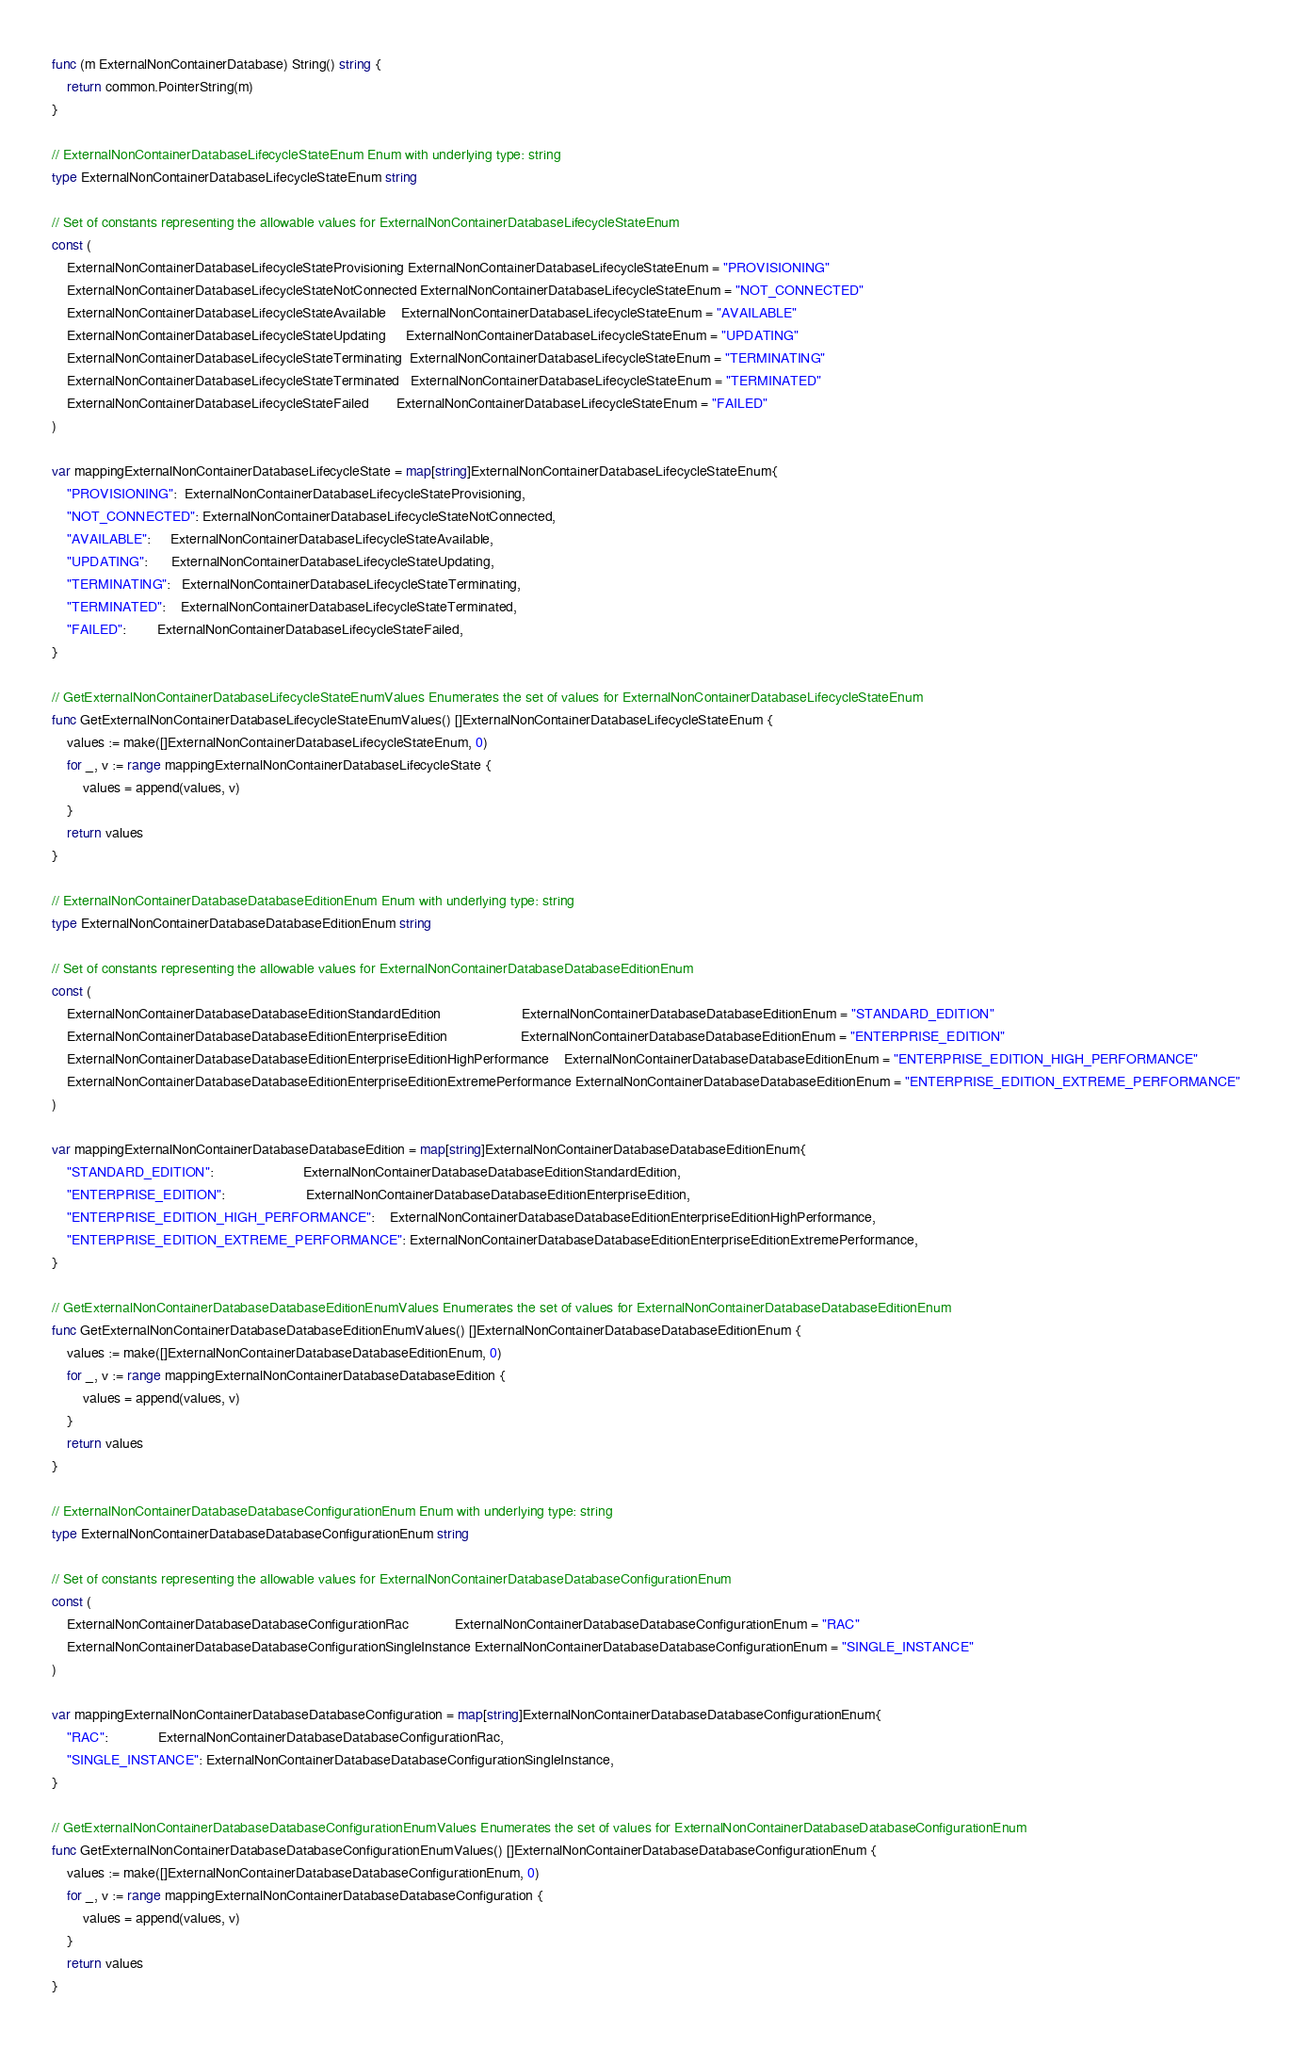<code> <loc_0><loc_0><loc_500><loc_500><_Go_>func (m ExternalNonContainerDatabase) String() string {
	return common.PointerString(m)
}

// ExternalNonContainerDatabaseLifecycleStateEnum Enum with underlying type: string
type ExternalNonContainerDatabaseLifecycleStateEnum string

// Set of constants representing the allowable values for ExternalNonContainerDatabaseLifecycleStateEnum
const (
	ExternalNonContainerDatabaseLifecycleStateProvisioning ExternalNonContainerDatabaseLifecycleStateEnum = "PROVISIONING"
	ExternalNonContainerDatabaseLifecycleStateNotConnected ExternalNonContainerDatabaseLifecycleStateEnum = "NOT_CONNECTED"
	ExternalNonContainerDatabaseLifecycleStateAvailable    ExternalNonContainerDatabaseLifecycleStateEnum = "AVAILABLE"
	ExternalNonContainerDatabaseLifecycleStateUpdating     ExternalNonContainerDatabaseLifecycleStateEnum = "UPDATING"
	ExternalNonContainerDatabaseLifecycleStateTerminating  ExternalNonContainerDatabaseLifecycleStateEnum = "TERMINATING"
	ExternalNonContainerDatabaseLifecycleStateTerminated   ExternalNonContainerDatabaseLifecycleStateEnum = "TERMINATED"
	ExternalNonContainerDatabaseLifecycleStateFailed       ExternalNonContainerDatabaseLifecycleStateEnum = "FAILED"
)

var mappingExternalNonContainerDatabaseLifecycleState = map[string]ExternalNonContainerDatabaseLifecycleStateEnum{
	"PROVISIONING":  ExternalNonContainerDatabaseLifecycleStateProvisioning,
	"NOT_CONNECTED": ExternalNonContainerDatabaseLifecycleStateNotConnected,
	"AVAILABLE":     ExternalNonContainerDatabaseLifecycleStateAvailable,
	"UPDATING":      ExternalNonContainerDatabaseLifecycleStateUpdating,
	"TERMINATING":   ExternalNonContainerDatabaseLifecycleStateTerminating,
	"TERMINATED":    ExternalNonContainerDatabaseLifecycleStateTerminated,
	"FAILED":        ExternalNonContainerDatabaseLifecycleStateFailed,
}

// GetExternalNonContainerDatabaseLifecycleStateEnumValues Enumerates the set of values for ExternalNonContainerDatabaseLifecycleStateEnum
func GetExternalNonContainerDatabaseLifecycleStateEnumValues() []ExternalNonContainerDatabaseLifecycleStateEnum {
	values := make([]ExternalNonContainerDatabaseLifecycleStateEnum, 0)
	for _, v := range mappingExternalNonContainerDatabaseLifecycleState {
		values = append(values, v)
	}
	return values
}

// ExternalNonContainerDatabaseDatabaseEditionEnum Enum with underlying type: string
type ExternalNonContainerDatabaseDatabaseEditionEnum string

// Set of constants representing the allowable values for ExternalNonContainerDatabaseDatabaseEditionEnum
const (
	ExternalNonContainerDatabaseDatabaseEditionStandardEdition                     ExternalNonContainerDatabaseDatabaseEditionEnum = "STANDARD_EDITION"
	ExternalNonContainerDatabaseDatabaseEditionEnterpriseEdition                   ExternalNonContainerDatabaseDatabaseEditionEnum = "ENTERPRISE_EDITION"
	ExternalNonContainerDatabaseDatabaseEditionEnterpriseEditionHighPerformance    ExternalNonContainerDatabaseDatabaseEditionEnum = "ENTERPRISE_EDITION_HIGH_PERFORMANCE"
	ExternalNonContainerDatabaseDatabaseEditionEnterpriseEditionExtremePerformance ExternalNonContainerDatabaseDatabaseEditionEnum = "ENTERPRISE_EDITION_EXTREME_PERFORMANCE"
)

var mappingExternalNonContainerDatabaseDatabaseEdition = map[string]ExternalNonContainerDatabaseDatabaseEditionEnum{
	"STANDARD_EDITION":                       ExternalNonContainerDatabaseDatabaseEditionStandardEdition,
	"ENTERPRISE_EDITION":                     ExternalNonContainerDatabaseDatabaseEditionEnterpriseEdition,
	"ENTERPRISE_EDITION_HIGH_PERFORMANCE":    ExternalNonContainerDatabaseDatabaseEditionEnterpriseEditionHighPerformance,
	"ENTERPRISE_EDITION_EXTREME_PERFORMANCE": ExternalNonContainerDatabaseDatabaseEditionEnterpriseEditionExtremePerformance,
}

// GetExternalNonContainerDatabaseDatabaseEditionEnumValues Enumerates the set of values for ExternalNonContainerDatabaseDatabaseEditionEnum
func GetExternalNonContainerDatabaseDatabaseEditionEnumValues() []ExternalNonContainerDatabaseDatabaseEditionEnum {
	values := make([]ExternalNonContainerDatabaseDatabaseEditionEnum, 0)
	for _, v := range mappingExternalNonContainerDatabaseDatabaseEdition {
		values = append(values, v)
	}
	return values
}

// ExternalNonContainerDatabaseDatabaseConfigurationEnum Enum with underlying type: string
type ExternalNonContainerDatabaseDatabaseConfigurationEnum string

// Set of constants representing the allowable values for ExternalNonContainerDatabaseDatabaseConfigurationEnum
const (
	ExternalNonContainerDatabaseDatabaseConfigurationRac            ExternalNonContainerDatabaseDatabaseConfigurationEnum = "RAC"
	ExternalNonContainerDatabaseDatabaseConfigurationSingleInstance ExternalNonContainerDatabaseDatabaseConfigurationEnum = "SINGLE_INSTANCE"
)

var mappingExternalNonContainerDatabaseDatabaseConfiguration = map[string]ExternalNonContainerDatabaseDatabaseConfigurationEnum{
	"RAC":             ExternalNonContainerDatabaseDatabaseConfigurationRac,
	"SINGLE_INSTANCE": ExternalNonContainerDatabaseDatabaseConfigurationSingleInstance,
}

// GetExternalNonContainerDatabaseDatabaseConfigurationEnumValues Enumerates the set of values for ExternalNonContainerDatabaseDatabaseConfigurationEnum
func GetExternalNonContainerDatabaseDatabaseConfigurationEnumValues() []ExternalNonContainerDatabaseDatabaseConfigurationEnum {
	values := make([]ExternalNonContainerDatabaseDatabaseConfigurationEnum, 0)
	for _, v := range mappingExternalNonContainerDatabaseDatabaseConfiguration {
		values = append(values, v)
	}
	return values
}
</code> 